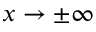Convert formula to latex. <formula><loc_0><loc_0><loc_500><loc_500>x \rightarrow \pm \infty</formula> 